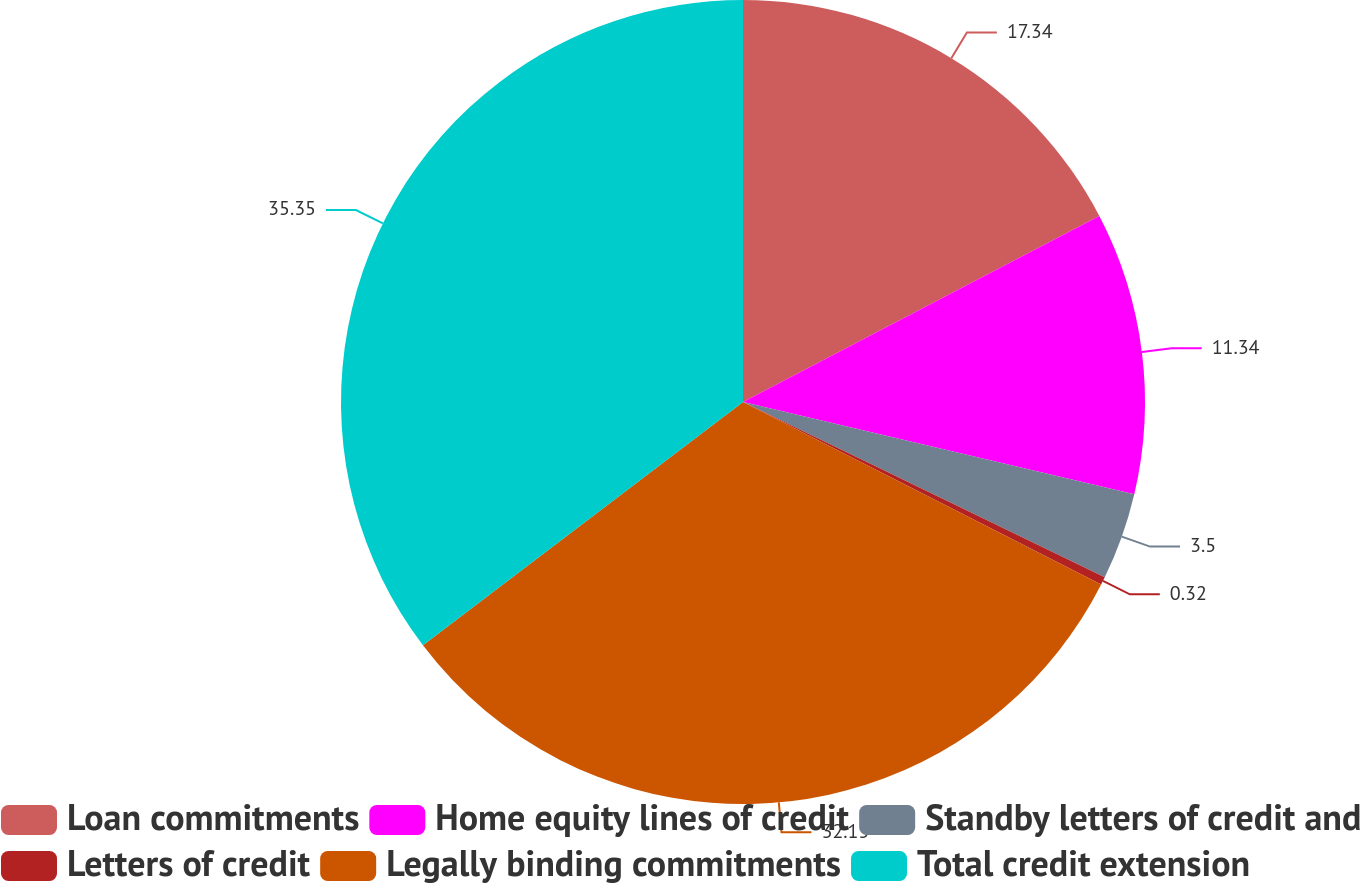Convert chart to OTSL. <chart><loc_0><loc_0><loc_500><loc_500><pie_chart><fcel>Loan commitments<fcel>Home equity lines of credit<fcel>Standby letters of credit and<fcel>Letters of credit<fcel>Legally binding commitments<fcel>Total credit extension<nl><fcel>17.34%<fcel>11.34%<fcel>3.5%<fcel>0.32%<fcel>32.15%<fcel>35.34%<nl></chart> 